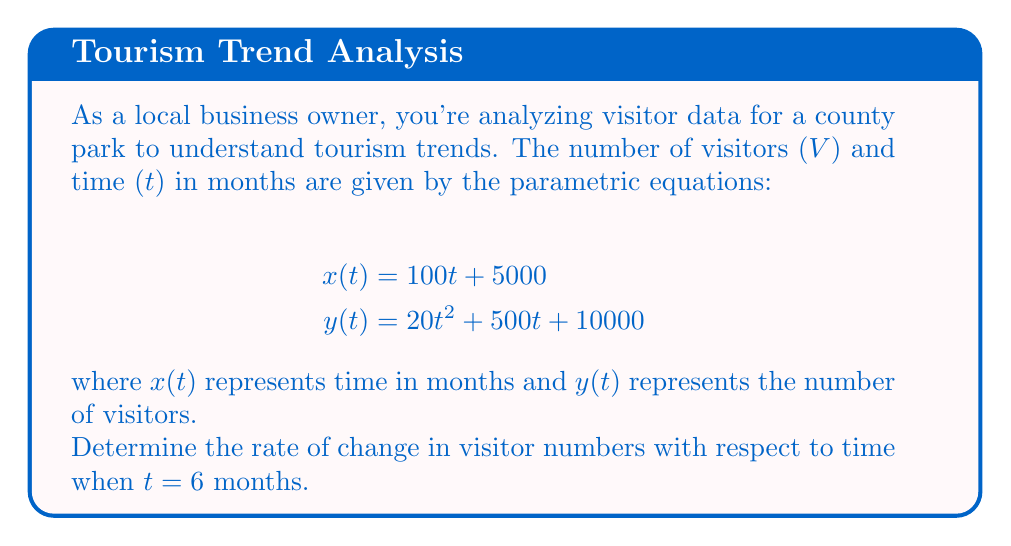What is the answer to this math problem? To find the rate of change in visitor numbers with respect to time, we need to calculate dy/dx at t = 6. We'll use the chain rule for parametric equations:

1) First, find dx/dt and dy/dt:
   $$\frac{dx}{dt} = 100$$
   $$\frac{dy}{dt} = 40t + 500$$

2) The rate of change is given by:
   $$\frac{dy}{dx} = \frac{dy/dt}{dx/dt}$$

3) Substitute the expressions:
   $$\frac{dy}{dx} = \frac{40t + 500}{100}$$

4) Simplify:
   $$\frac{dy}{dx} = 0.4t + 5$$

5) Now, evaluate at t = 6:
   $$\frac{dy}{dx}\bigg|_{t=6} = 0.4(6) + 5 = 2.4 + 5 = 7.4$$

Therefore, the rate of change in visitor numbers with respect to time at t = 6 months is 7.4 visitors per month.
Answer: 7.4 visitors/month 